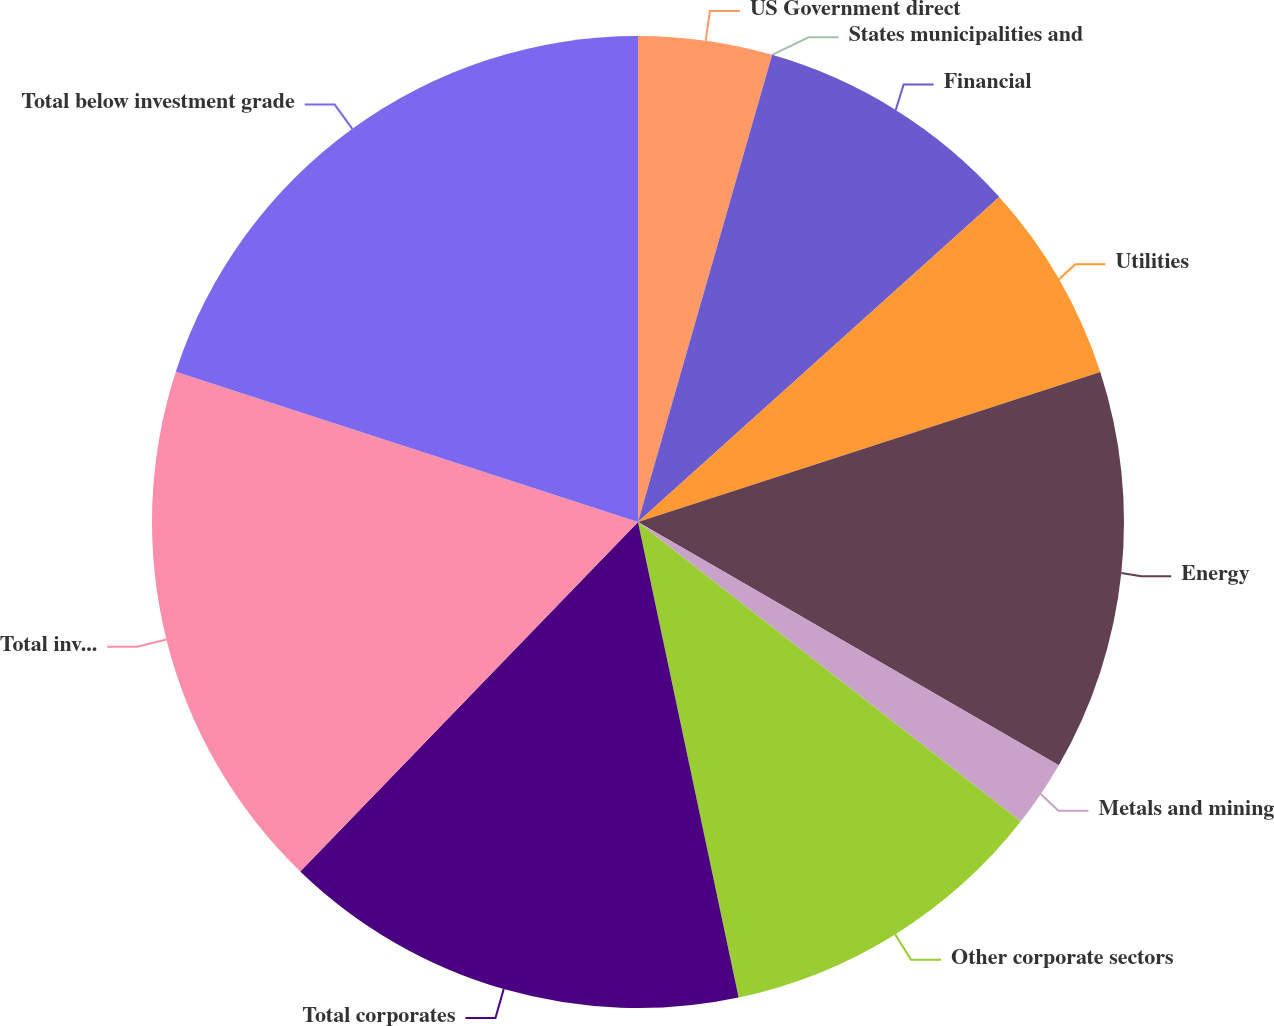Convert chart. <chart><loc_0><loc_0><loc_500><loc_500><pie_chart><fcel>US Government direct<fcel>States municipalities and<fcel>Financial<fcel>Utilities<fcel>Energy<fcel>Metals and mining<fcel>Other corporate sectors<fcel>Total corporates<fcel>Total investment grade<fcel>Total below investment grade<nl><fcel>4.45%<fcel>0.0%<fcel>8.89%<fcel>6.67%<fcel>13.33%<fcel>2.23%<fcel>11.11%<fcel>15.55%<fcel>17.77%<fcel>20.0%<nl></chart> 